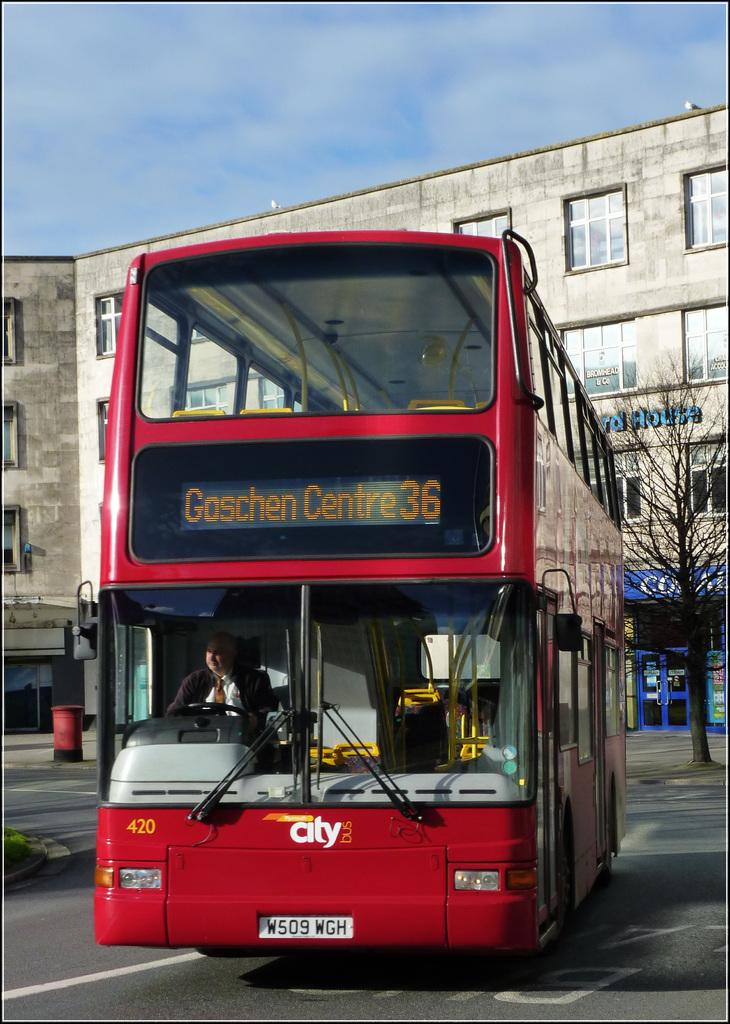<image>
Summarize the visual content of the image. Double Decker bus with a white front tag with W509 WGH on the front bumper. 